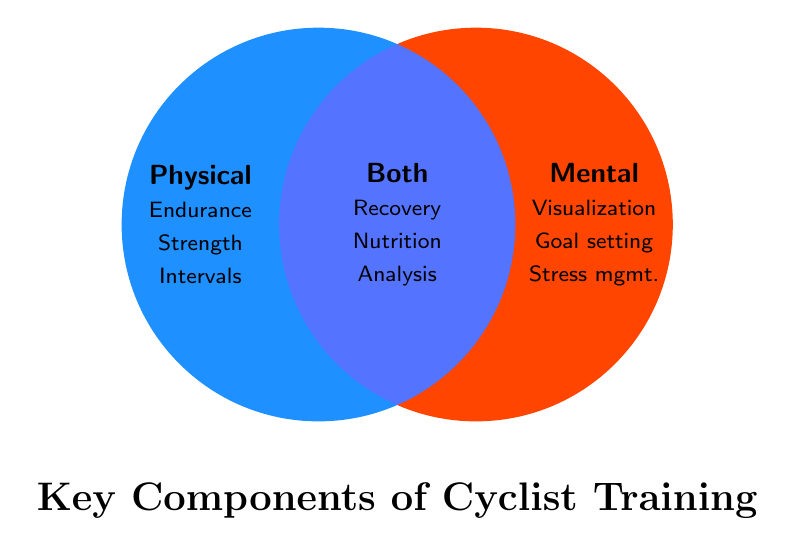What are the key components of a cyclist's training regimen? The title at the bottom of the Venn Diagram is "Key Components of Cyclist Training".
Answer: Key Components of Cyclist Training Which category includes Goal setting? Check the Mental section on the right side of the Venn Diagram. Goal setting is listed under Mental.
Answer: Mental What components fall under both Physical and Mental training? Look at the intersection of the two circles where both colors overlap. The components listed there are Recovery, Nutrition, and Analysis.
Answer: Recovery, Nutrition, and Analysis Which category includes Interval training? Refer to the Physical section on the left side of the diagram. Interval training is listed under Physical.
Answer: Physical How many components are listed in the Physical section? Count the number of items in the Physical section on the left: Endurance, Strength, and Intervals. There are 3 components.
Answer: 3 Compare the number of components in the Physical and Mental categories. Which has more? Count the components in each section. Physical has 3 components (Endurance training, Strength training, Interval training) and Mental also has 3 components (Visualization, Goal setting, Stress management). Both have the same number of components.
Answer: Equal Which components involve both physical and mental aspects of training? The intersection of the two categories lists components that involve both aspects: Recovery, Nutrition, and Analysis.
Answer: Recovery, Nutrition, Analysis How does Nutrition planning fit into the categories? Look at the overlapping section (intersection) of the Venn Diagram. Nutrition planning is listed as a component under Both Physical and Mental.
Answer: Both Is Visualization a part of Physical training? Check the sections of the diagram. Visualization is listed under Mental training, not Physical.
Answer: No 